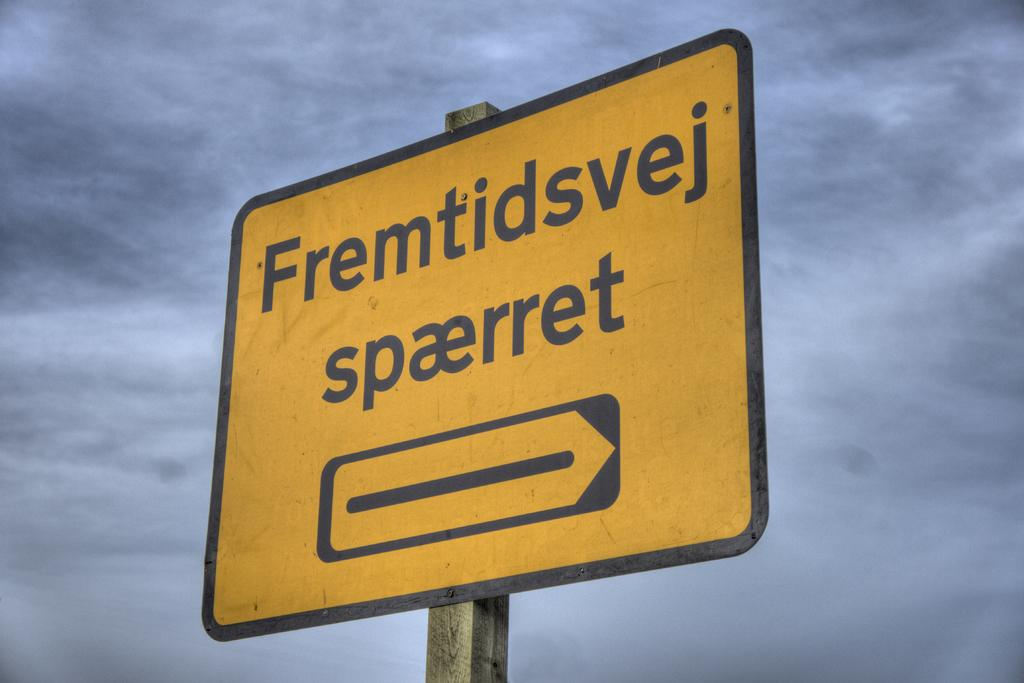<image>
Describe the image concisely. Yellow street sign that says "Fremtidsvej" on it. 